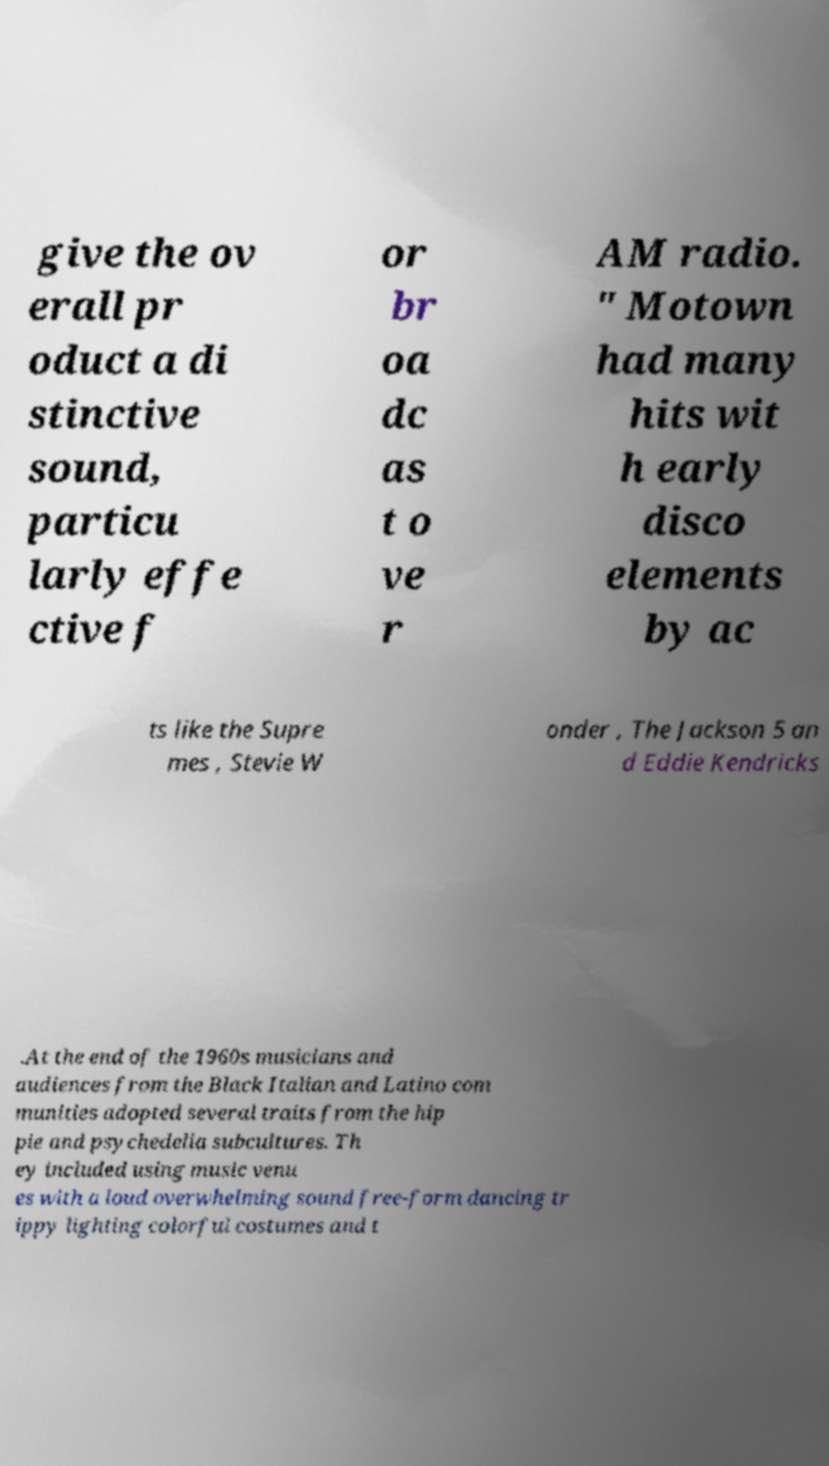There's text embedded in this image that I need extracted. Can you transcribe it verbatim? give the ov erall pr oduct a di stinctive sound, particu larly effe ctive f or br oa dc as t o ve r AM radio. " Motown had many hits wit h early disco elements by ac ts like the Supre mes , Stevie W onder , The Jackson 5 an d Eddie Kendricks .At the end of the 1960s musicians and audiences from the Black Italian and Latino com munities adopted several traits from the hip pie and psychedelia subcultures. Th ey included using music venu es with a loud overwhelming sound free-form dancing tr ippy lighting colorful costumes and t 